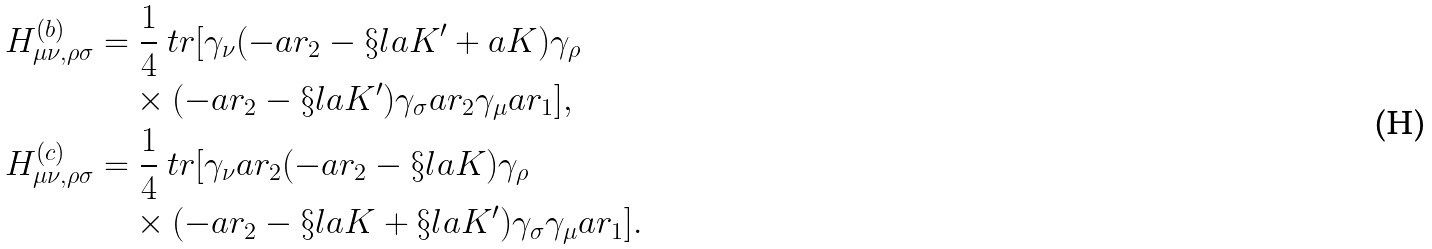Convert formula to latex. <formula><loc_0><loc_0><loc_500><loc_500>H ^ { ( b ) } _ { \mu \nu , \rho \sigma } & = \frac { 1 } { 4 } \ t r [ \gamma _ { \nu } ( - \sl a { r } _ { 2 } - \S l a { K } ^ { \prime } + \sl a { K } ) \gamma _ { \rho } \\ & \quad \times ( - \sl a { r } _ { 2 } - \S l a { K } ^ { \prime } ) \gamma _ { \sigma } \sl a { r } _ { 2 } \gamma _ { \mu } \sl a { r } _ { 1 } ] , \\ H ^ { ( c ) } _ { \mu \nu , \rho \sigma } & = \frac { 1 } { 4 } \ t r [ \gamma _ { \nu } \sl a { r } _ { 2 } ( - \sl a { r } _ { 2 } - \S l a { K } ) \gamma _ { \rho } \\ & \quad \times ( - \sl a { r } _ { 2 } - \S l a { K } + \S l a { K } ^ { \prime } ) \gamma _ { \sigma } \gamma _ { \mu } \sl a { r } _ { 1 } ] .</formula> 